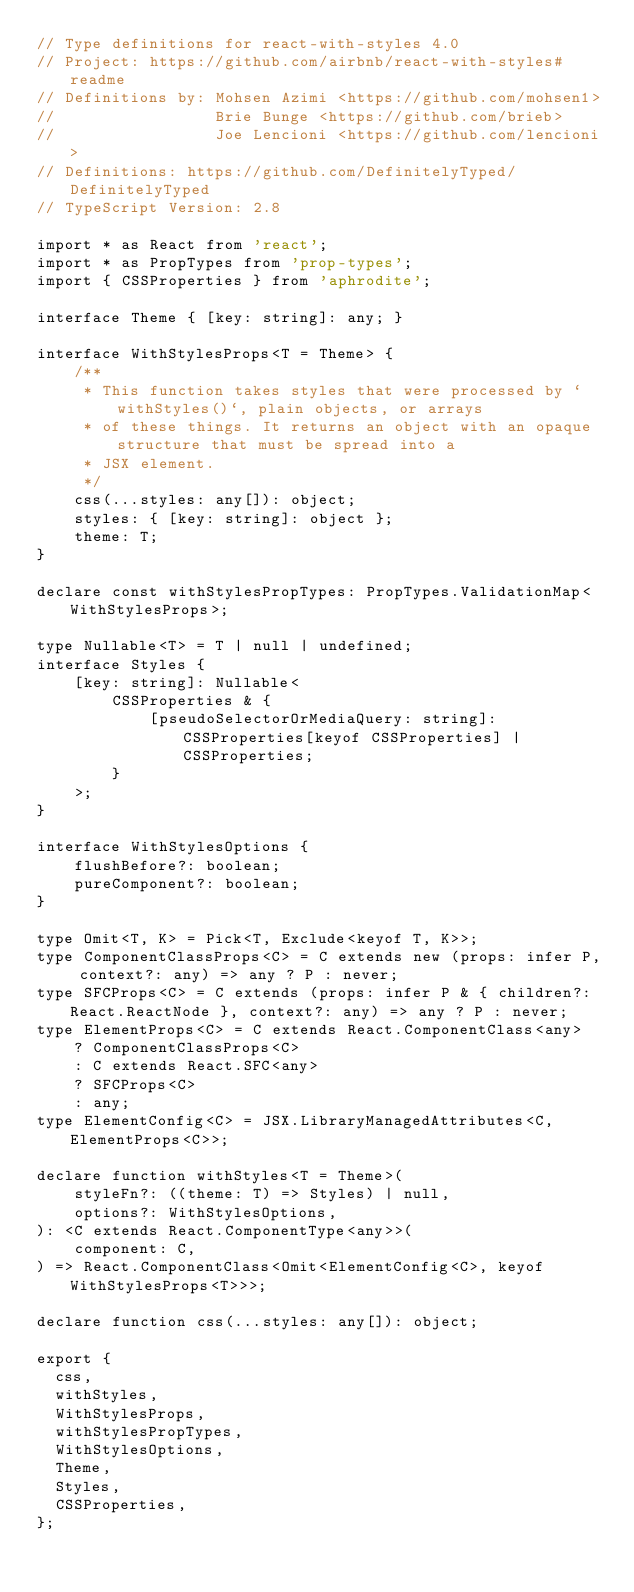<code> <loc_0><loc_0><loc_500><loc_500><_TypeScript_>// Type definitions for react-with-styles 4.0
// Project: https://github.com/airbnb/react-with-styles#readme
// Definitions by: Mohsen Azimi <https://github.com/mohsen1>
//                 Brie Bunge <https://github.com/brieb>
//                 Joe Lencioni <https://github.com/lencioni>
// Definitions: https://github.com/DefinitelyTyped/DefinitelyTyped
// TypeScript Version: 2.8

import * as React from 'react';
import * as PropTypes from 'prop-types';
import { CSSProperties } from 'aphrodite';

interface Theme { [key: string]: any; }

interface WithStylesProps<T = Theme> {
    /**
     * This function takes styles that were processed by `withStyles()`, plain objects, or arrays
     * of these things. It returns an object with an opaque structure that must be spread into a
     * JSX element.
     */
    css(...styles: any[]): object;
    styles: { [key: string]: object };
    theme: T;
}

declare const withStylesPropTypes: PropTypes.ValidationMap<WithStylesProps>;

type Nullable<T> = T | null | undefined;
interface Styles {
    [key: string]: Nullable<
        CSSProperties & {
            [pseudoSelectorOrMediaQuery: string]: CSSProperties[keyof CSSProperties] | CSSProperties;
        }
    >;
}

interface WithStylesOptions {
    flushBefore?: boolean;
    pureComponent?: boolean;
}

type Omit<T, K> = Pick<T, Exclude<keyof T, K>>;
type ComponentClassProps<C> = C extends new (props: infer P, context?: any) => any ? P : never;
type SFCProps<C> = C extends (props: infer P & { children?: React.ReactNode }, context?: any) => any ? P : never;
type ElementProps<C> = C extends React.ComponentClass<any>
    ? ComponentClassProps<C>
    : C extends React.SFC<any>
    ? SFCProps<C>
    : any;
type ElementConfig<C> = JSX.LibraryManagedAttributes<C, ElementProps<C>>;

declare function withStyles<T = Theme>(
    styleFn?: ((theme: T) => Styles) | null,
    options?: WithStylesOptions,
): <C extends React.ComponentType<any>>(
    component: C,
) => React.ComponentClass<Omit<ElementConfig<C>, keyof WithStylesProps<T>>>;

declare function css(...styles: any[]): object;

export {
  css,
  withStyles,
  WithStylesProps,
  withStylesPropTypes,
  WithStylesOptions,
  Theme,
  Styles,
  CSSProperties,
};
</code> 